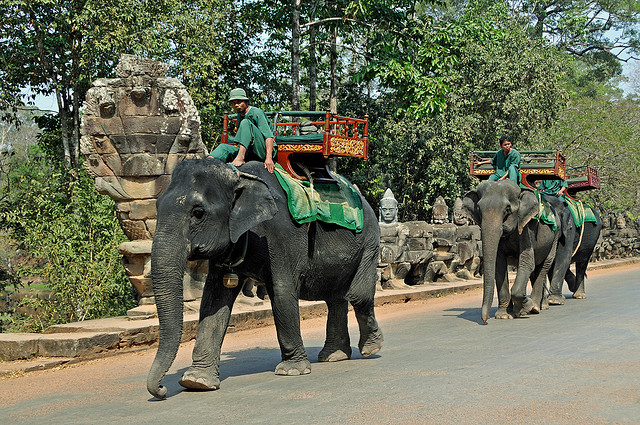Which country is famous for elephants?
A. dutch
B. norway
C. sydney
D. thailand
Answer with the option's letter from the given choices directly. Thailand (D) is renowned for its significant elephant population and the cultural importance of elephants within the country. These majestic creatures have been integral to Thai history, symbolizing power and peace, and are often featured in Thai mythology and artwork. Many tourists visit Thailand to experience elephant sanctuaries, where they can learn about and interact with these magnificent animals in a more natural and ethical environment. 